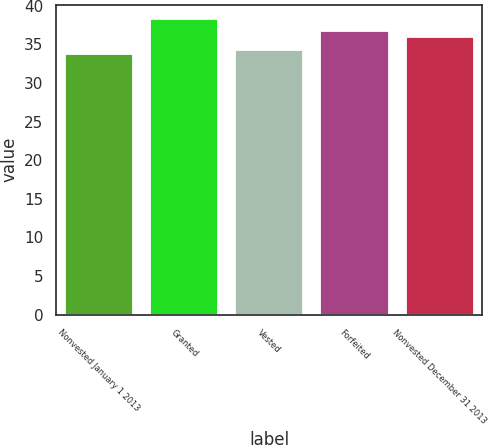<chart> <loc_0><loc_0><loc_500><loc_500><bar_chart><fcel>Nonvested January 1 2013<fcel>Granted<fcel>Vested<fcel>Forfeited<fcel>Nonvested December 31 2013<nl><fcel>33.78<fcel>38.25<fcel>34.23<fcel>36.71<fcel>35.98<nl></chart> 